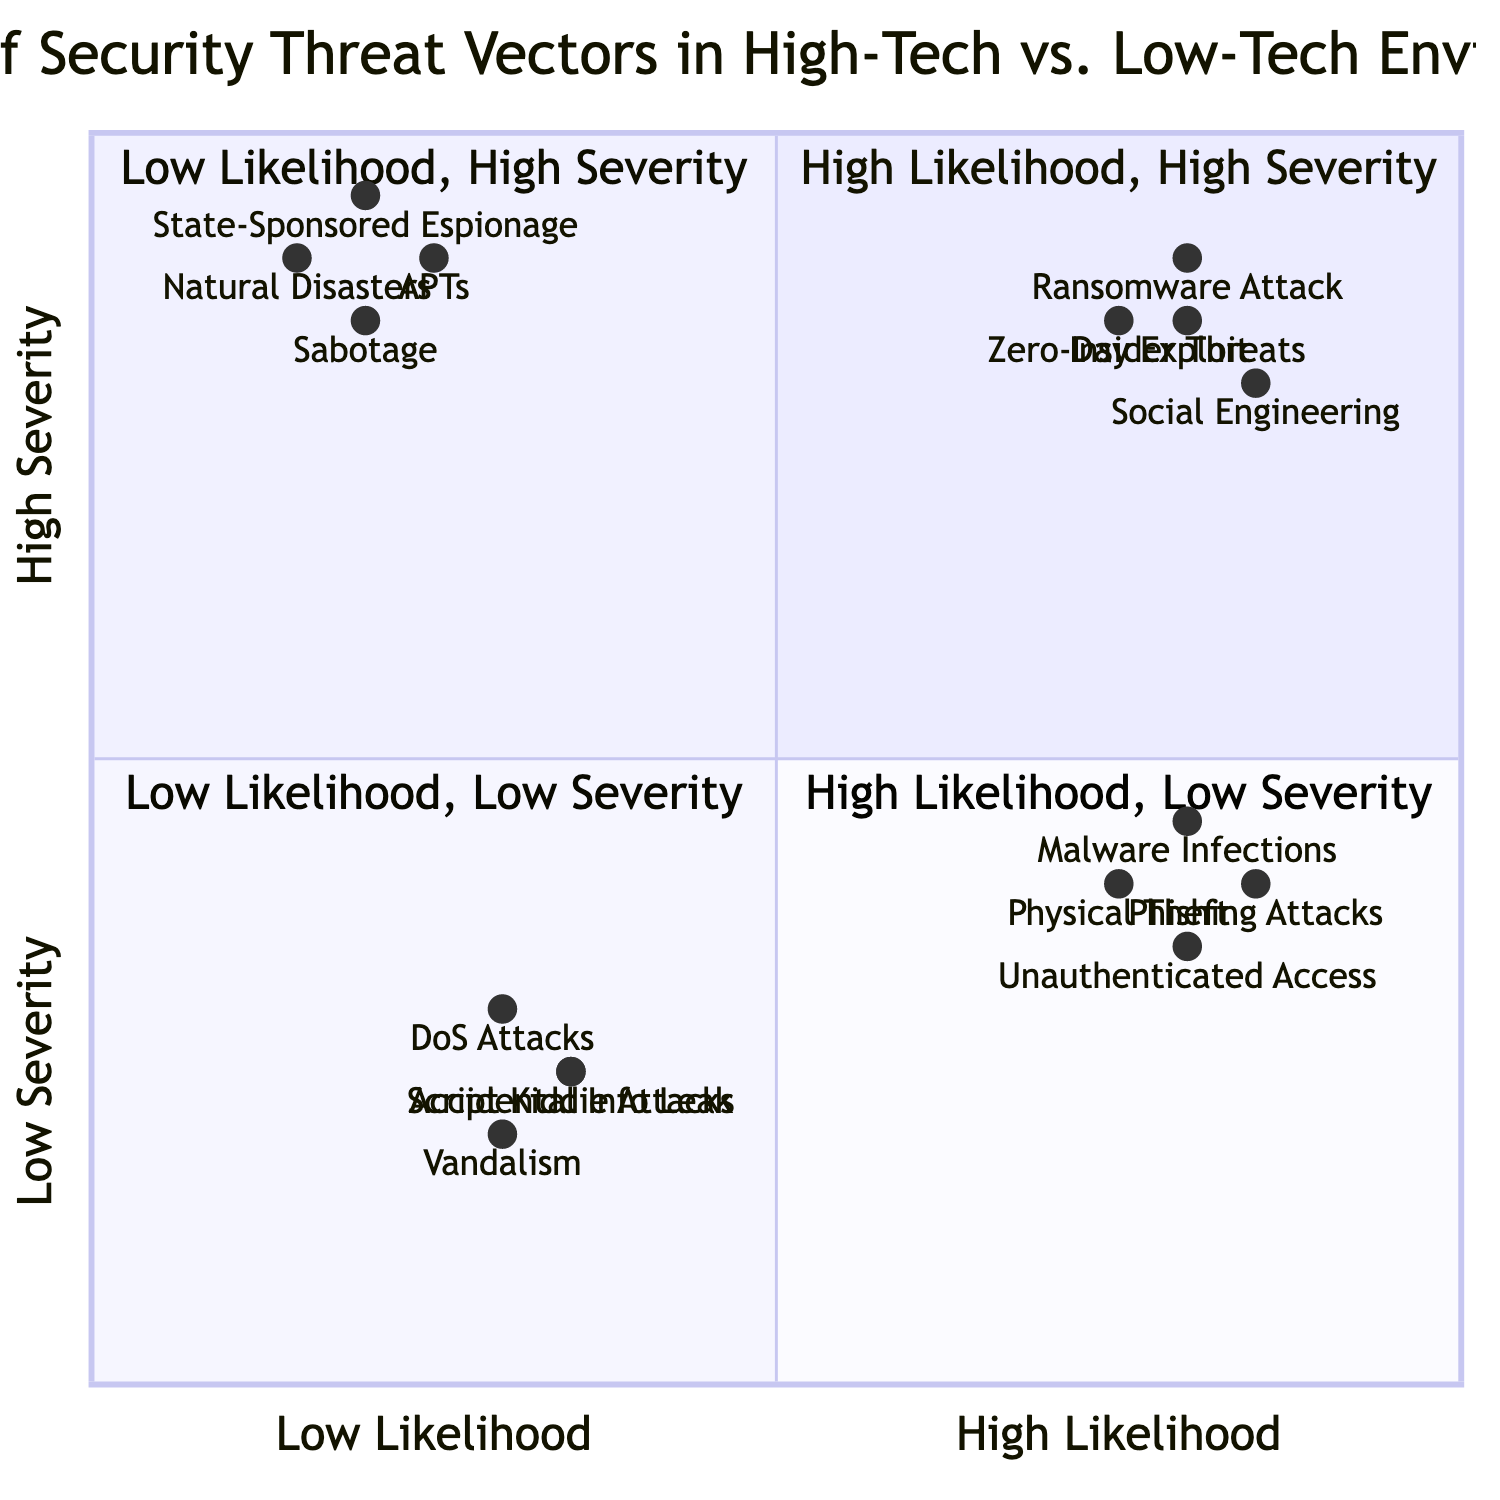What are the two threat vectors in the high likelihood, high severity quadrant for high-tech environments? In the high likelihood, high severity quadrant for high-tech environments, the threat vectors listed are "Ransomware Attack" and "Zero-Day Exploit."
Answer: Ransomware Attack, Zero-Day Exploit Which threat vector in the low likelihood, high severity quadrant for low-tech environments has the highest severity? Among the threat vectors listed in the low likelihood, high severity quadrant for low-tech environments, "Natural Disasters" is positioned at a severity level of 0.9, which is higher than the severity of "Sabotage," which is 0.85.
Answer: Natural Disasters Count the number of threat vectors in the high likelihood, low severity quadrant for high-tech environments. The high likelihood, low severity quadrant for high-tech environments contains two threat vectors: "Phishing Attacks" and "Malware Infections." Thus, the count is 2.
Answer: 2 Which environment has more severe threat vectors in the high likelihood, low severity category? When comparing the high likelihood, low severity category, the high-tech environment has "Phishing Attacks" with a severity of 0.4 and "Malware Infections" with 0.45, while the low-tech environment has "Physical Theft of Documents" (0.4) and "Unauthenticated Access" (0.35). The highest severity in the high-tech category (0.45) is greater than the highest in low-tech (0.4).
Answer: High-tech What is the most frequently occurring level of likelihood among the threat vectors displayed? A glance at the threat vectors shows that "high likelihood" is represented in three quadrants, while "low likelihood" is represented only in two quadrants, indicating that "high likelihood" occurs more frequently in the diagram.
Answer: High likelihood Which threat vector has the lowest severity in the low likelihood, low severity quadrant? In the low likelihood, low severity quadrant, both "Vandalism" and "Accidental Information Leak" have low severity scores. However, "Accidental Information Leak" has a severity of 0.25, which is lower than that of "Vandalism" at 0.2. Therefore, "Accidental Information Leak" is the one with the lowest severity.
Answer: Accidental Information Leak 